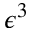Convert formula to latex. <formula><loc_0><loc_0><loc_500><loc_500>\epsilon ^ { 3 }</formula> 